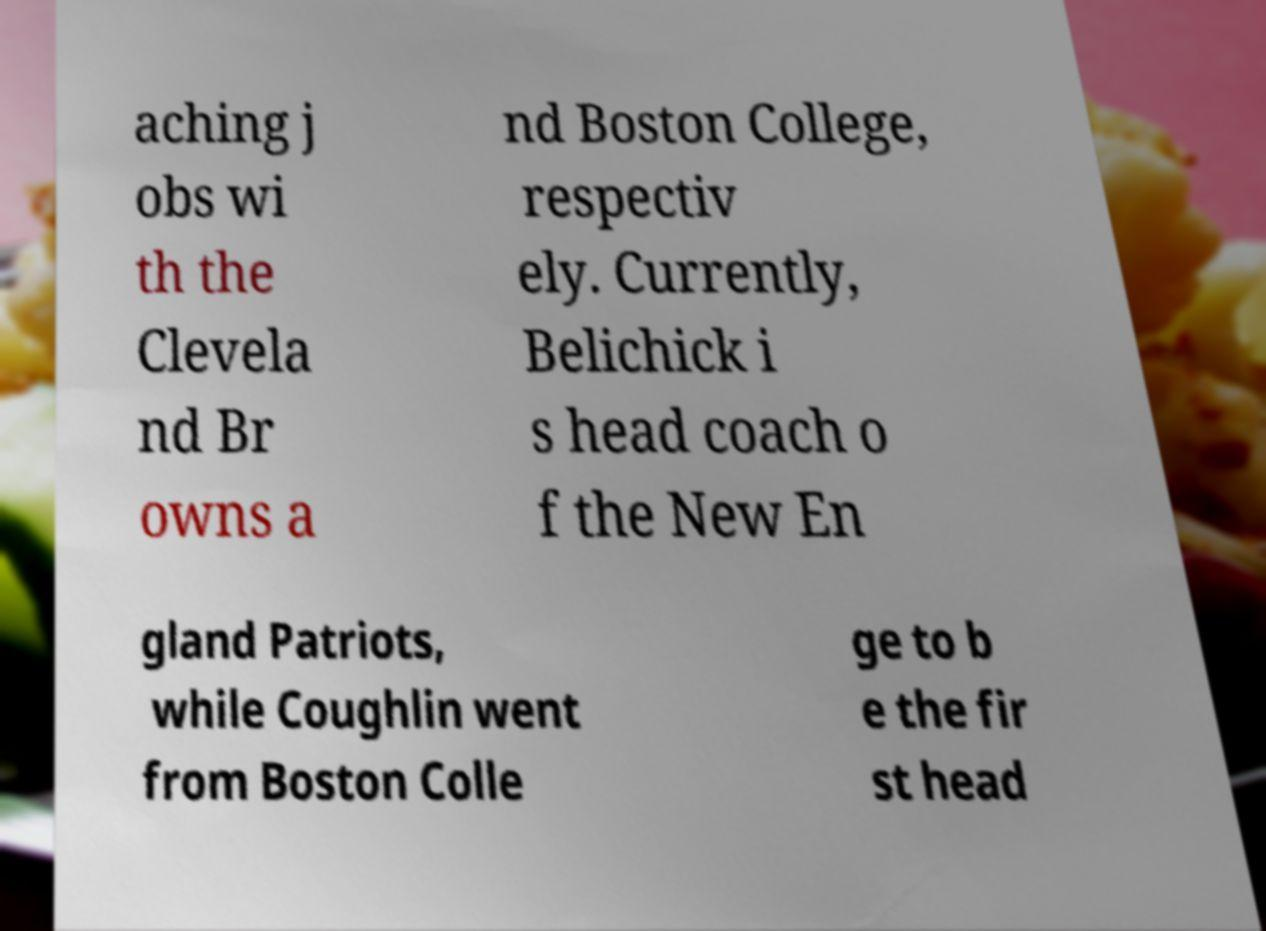What messages or text are displayed in this image? I need them in a readable, typed format. aching j obs wi th the Clevela nd Br owns a nd Boston College, respectiv ely. Currently, Belichick i s head coach o f the New En gland Patriots, while Coughlin went from Boston Colle ge to b e the fir st head 